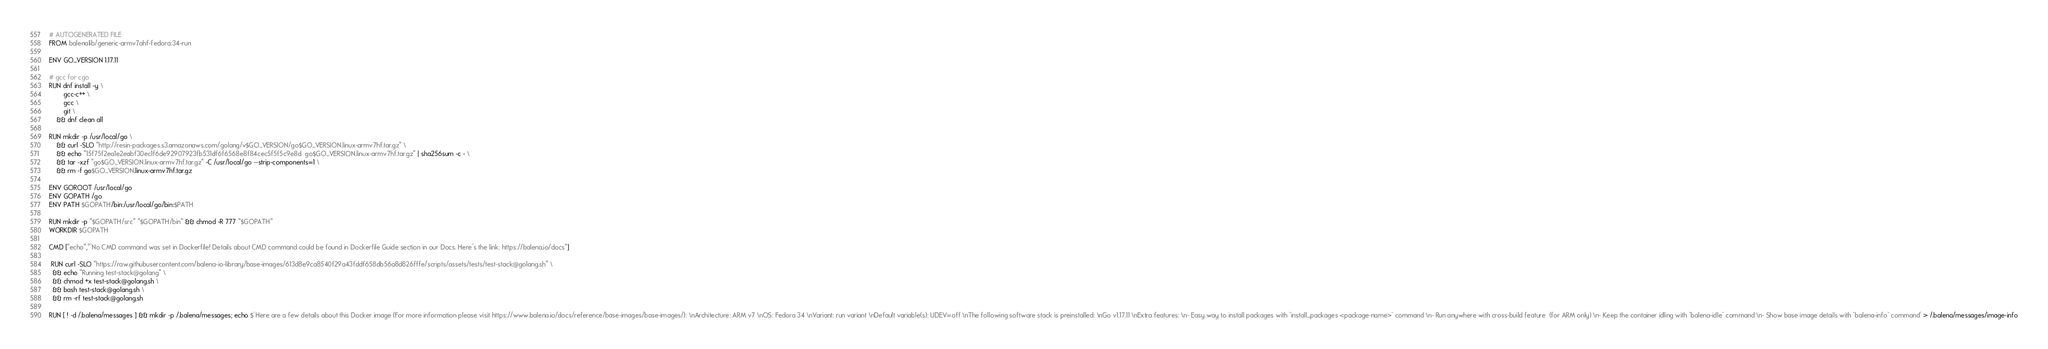Convert code to text. <code><loc_0><loc_0><loc_500><loc_500><_Dockerfile_># AUTOGENERATED FILE
FROM balenalib/generic-armv7ahf-fedora:34-run

ENV GO_VERSION 1.17.11

# gcc for cgo
RUN dnf install -y \
		gcc-c++ \
		gcc \
		git \
	&& dnf clean all

RUN mkdir -p /usr/local/go \
	&& curl -SLO "http://resin-packages.s3.amazonaws.com/golang/v$GO_VERSION/go$GO_VERSION.linux-armv7hf.tar.gz" \
	&& echo "15f75f2ea1e2eabf30ec1f6de92907923fb531df6f6568e8f84cec5f5f5c9e8d  go$GO_VERSION.linux-armv7hf.tar.gz" | sha256sum -c - \
	&& tar -xzf "go$GO_VERSION.linux-armv7hf.tar.gz" -C /usr/local/go --strip-components=1 \
	&& rm -f go$GO_VERSION.linux-armv7hf.tar.gz

ENV GOROOT /usr/local/go
ENV GOPATH /go
ENV PATH $GOPATH/bin:/usr/local/go/bin:$PATH

RUN mkdir -p "$GOPATH/src" "$GOPATH/bin" && chmod -R 777 "$GOPATH"
WORKDIR $GOPATH

CMD ["echo","'No CMD command was set in Dockerfile! Details about CMD command could be found in Dockerfile Guide section in our Docs. Here's the link: https://balena.io/docs"]

 RUN curl -SLO "https://raw.githubusercontent.com/balena-io-library/base-images/613d8e9ca8540f29a43fddf658db56a8d826fffe/scripts/assets/tests/test-stack@golang.sh" \
  && echo "Running test-stack@golang" \
  && chmod +x test-stack@golang.sh \
  && bash test-stack@golang.sh \
  && rm -rf test-stack@golang.sh 

RUN [ ! -d /.balena/messages ] && mkdir -p /.balena/messages; echo $'Here are a few details about this Docker image (For more information please visit https://www.balena.io/docs/reference/base-images/base-images/): \nArchitecture: ARM v7 \nOS: Fedora 34 \nVariant: run variant \nDefault variable(s): UDEV=off \nThe following software stack is preinstalled: \nGo v1.17.11 \nExtra features: \n- Easy way to install packages with `install_packages <package-name>` command \n- Run anywhere with cross-build feature  (for ARM only) \n- Keep the container idling with `balena-idle` command \n- Show base image details with `balena-info` command' > /.balena/messages/image-info</code> 